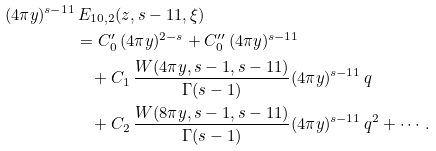Convert formula to latex. <formula><loc_0><loc_0><loc_500><loc_500>( 4 \pi y ) ^ { s - 1 1 } & \, E _ { 1 0 , 2 } ( z , s - 1 1 , \xi ) \\ & = C _ { 0 } ^ { \prime } \, ( 4 \pi y ) ^ { 2 - s } + C _ { 0 } ^ { \prime \prime } \, ( 4 \pi y ) ^ { s - 1 1 } \\ & \quad + C _ { 1 } \, \frac { W ( 4 \pi y , s - 1 , s - 1 1 ) } { \Gamma ( s - 1 ) } ( 4 \pi y ) ^ { s - 1 1 } \, q \\ & \quad + C _ { 2 } \, \frac { W ( 8 \pi y , s - 1 , s - 1 1 ) } { \Gamma ( s - 1 ) } ( 4 \pi y ) ^ { s - 1 1 } \, q ^ { 2 } + \cdots \, .</formula> 